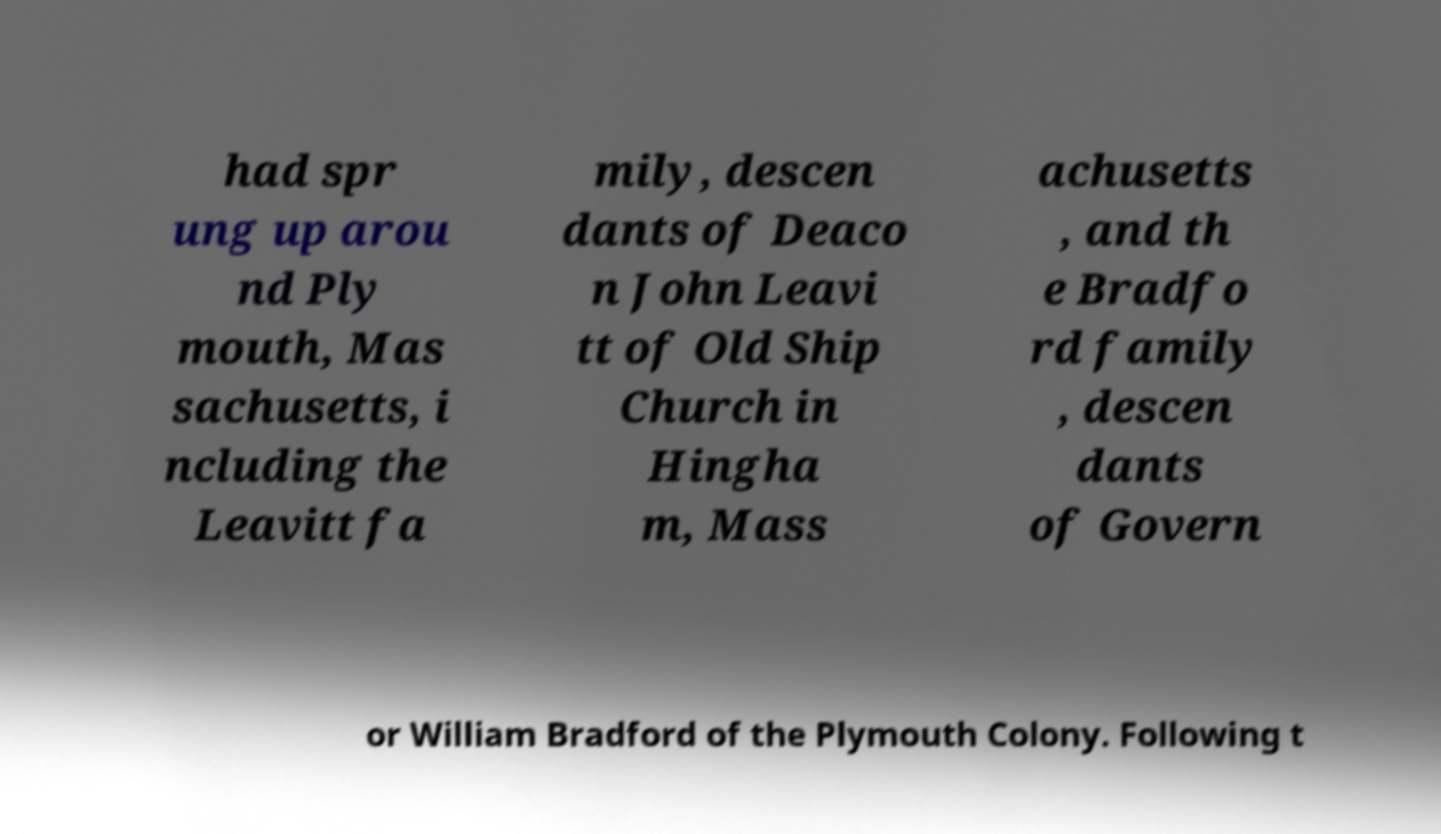Could you extract and type out the text from this image? had spr ung up arou nd Ply mouth, Mas sachusetts, i ncluding the Leavitt fa mily, descen dants of Deaco n John Leavi tt of Old Ship Church in Hingha m, Mass achusetts , and th e Bradfo rd family , descen dants of Govern or William Bradford of the Plymouth Colony. Following t 